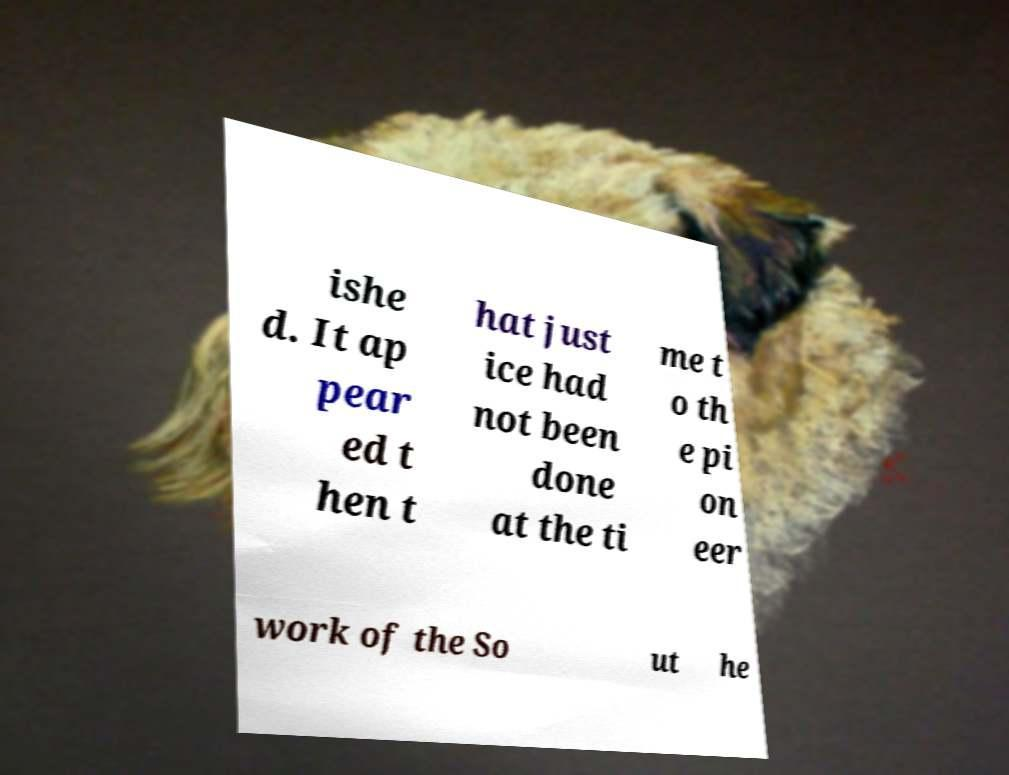Can you accurately transcribe the text from the provided image for me? ishe d. It ap pear ed t hen t hat just ice had not been done at the ti me t o th e pi on eer work of the So ut he 